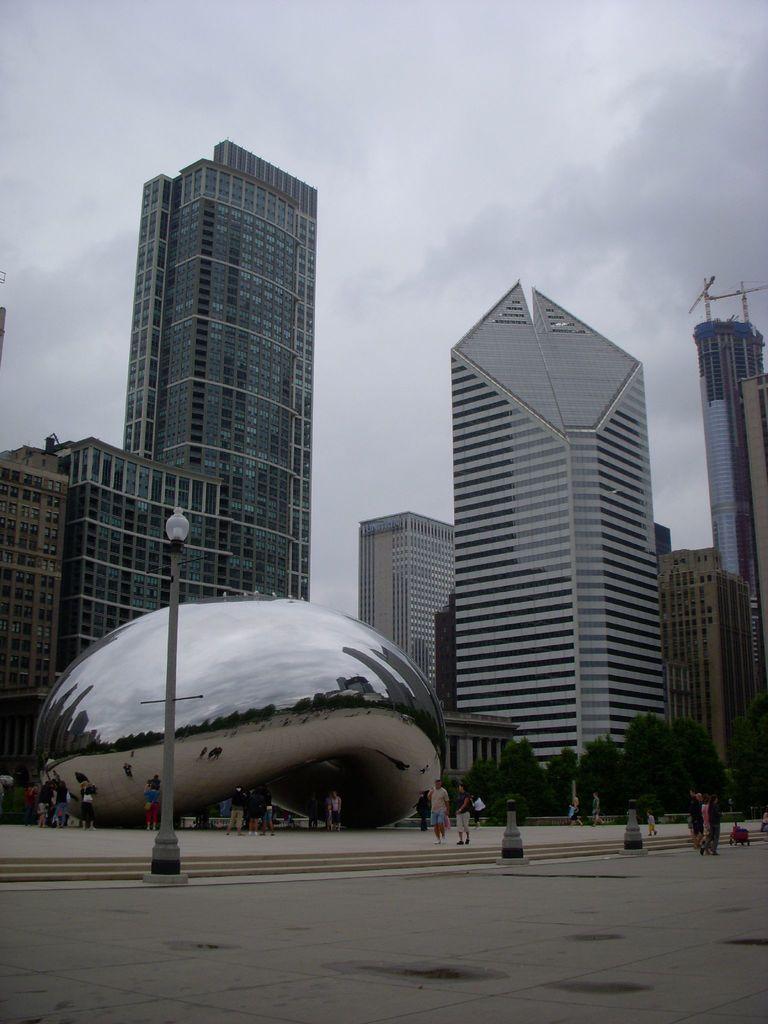Please provide a concise description of this image. In the picture we can see a path with some poles and lamps to it and behind it, we can see a shell type of construction and behind it, we can see some tower buildings and some trees near it and in the background we can see a sky and clouds. 